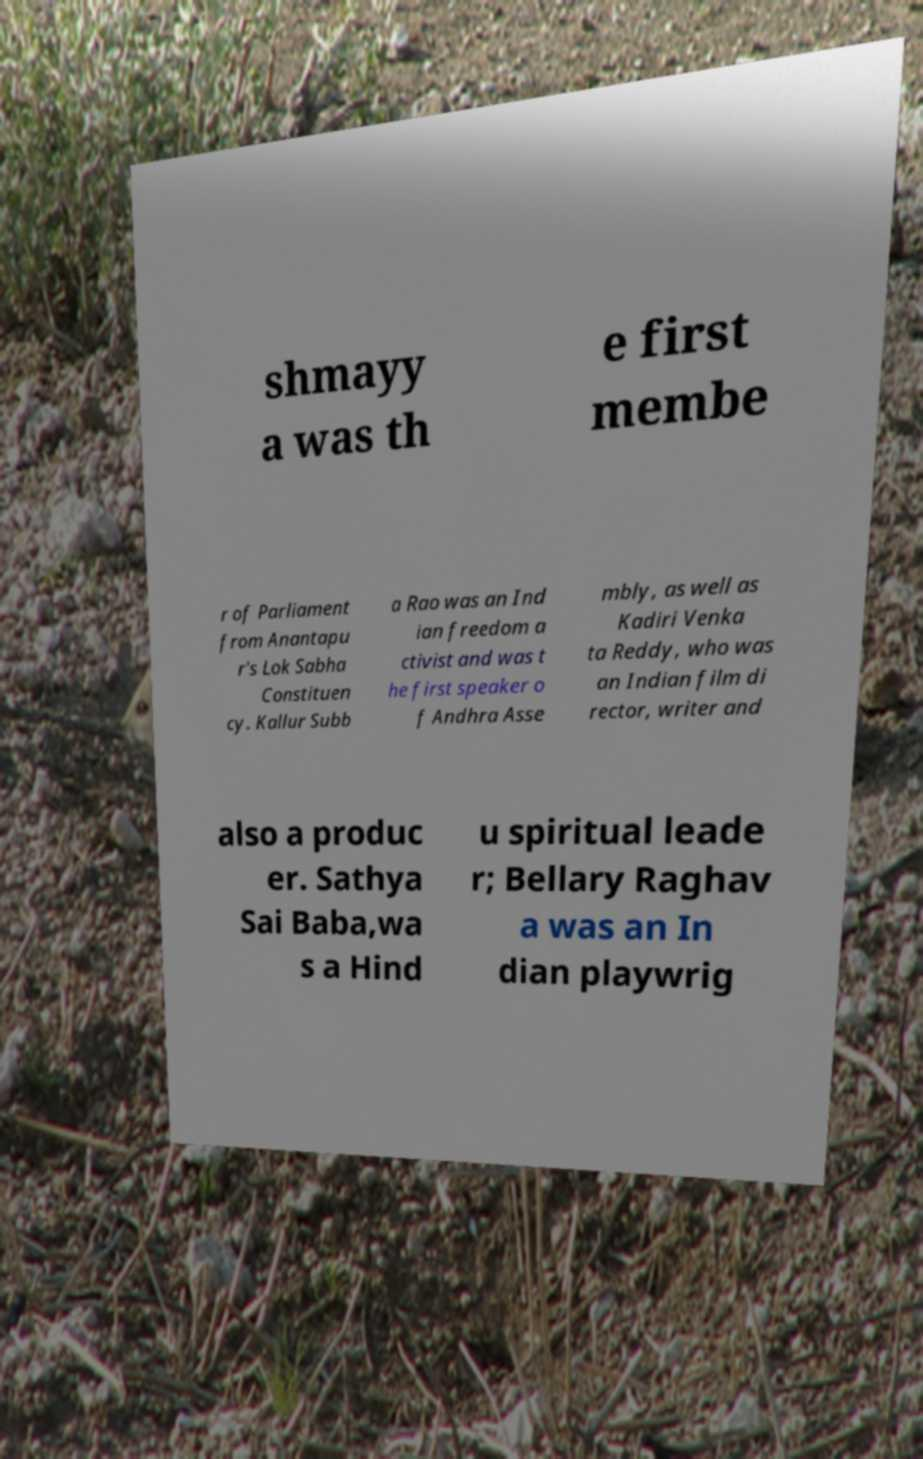Could you extract and type out the text from this image? shmayy a was th e first membe r of Parliament from Anantapu r's Lok Sabha Constituen cy. Kallur Subb a Rao was an Ind ian freedom a ctivist and was t he first speaker o f Andhra Asse mbly, as well as Kadiri Venka ta Reddy, who was an Indian film di rector, writer and also a produc er. Sathya Sai Baba,wa s a Hind u spiritual leade r; Bellary Raghav a was an In dian playwrig 